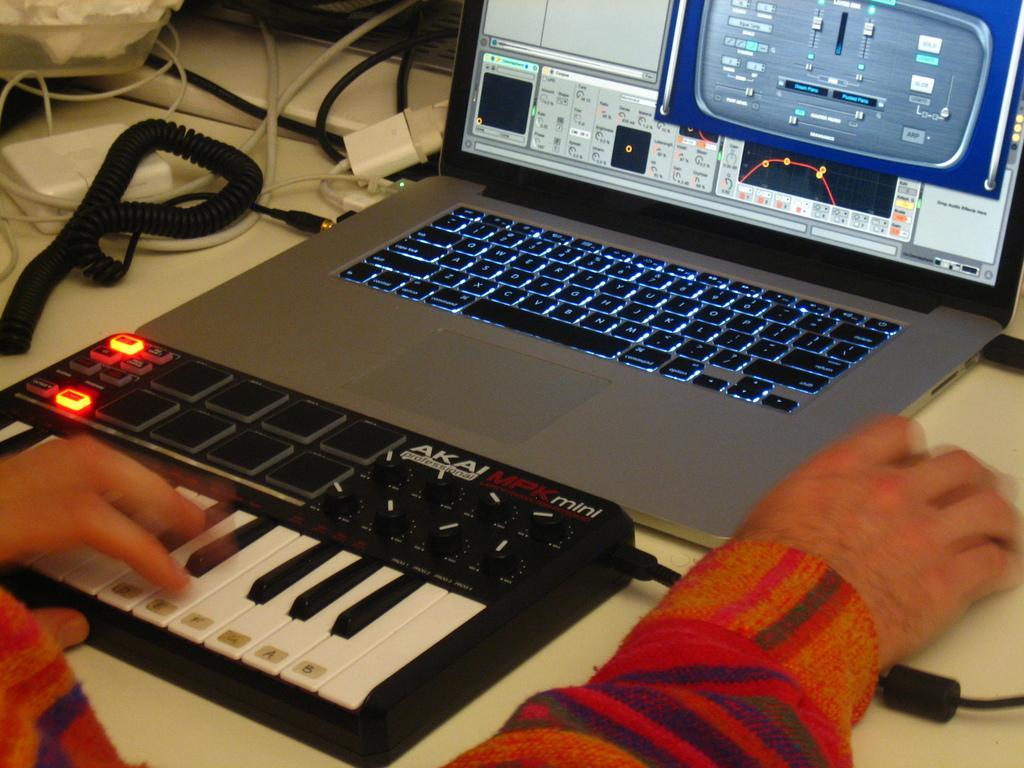In one or two sentences, can you explain what this image depicts? In this image there is a laptop truncated towards the top of the image, there is a musical instrument on the surface, there are hands of the person truncated, there are objects on the surface, there is an object truncated towards the top of the image, there are wires, there is an object truncated towards the right of the image. 